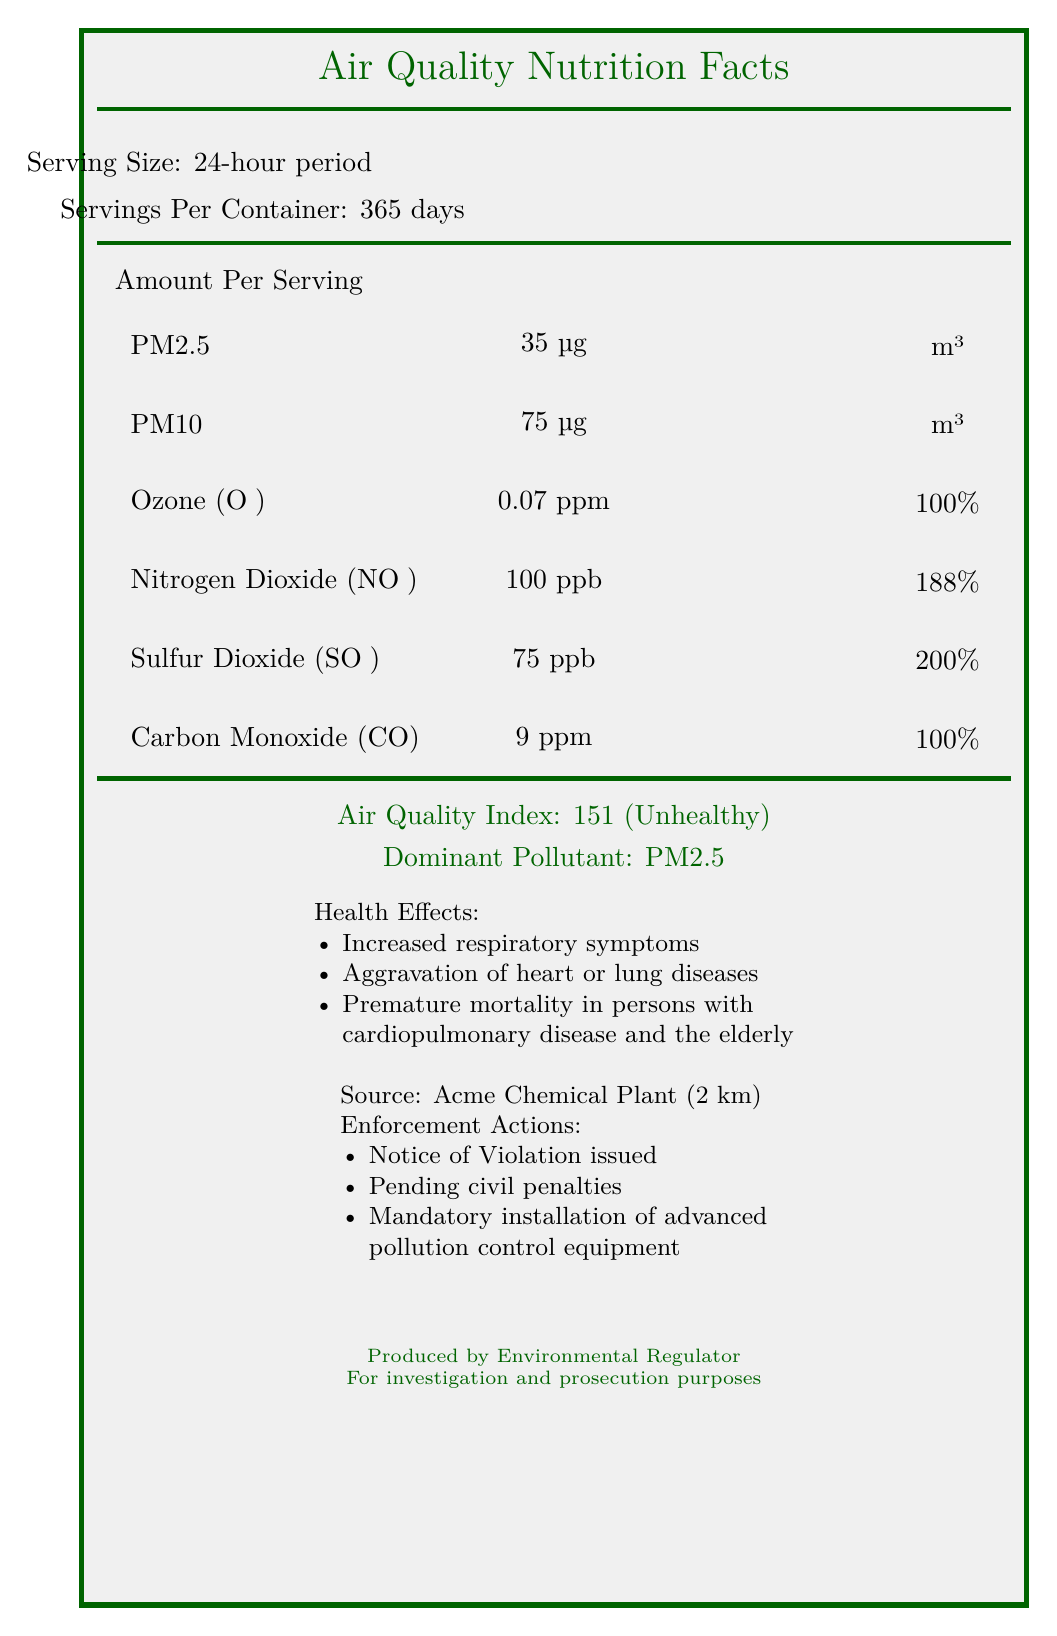who is responsible for the air quality contamination? The document explicitly states that Acme Chemical Plant is the source facility responsible for the contamination.
Answer: Acme Chemical Plant what is the serving size of air quality measurement? The document lists the serving size as a 24-hour period in the "Serving Size" section.
Answer: 24-hour period what is the air quality index (AQI) category? The document specifies that the Air Quality Index (AQI) is 151, which falls in the "Unhealthy" category.
Answer: Unhealthy what is the dominant pollutant in the air quality? The document states that the dominant pollutant is PM2.5.
Answer: PM2.5 how many schools and hospitals are affected by the pollution? According to the document, 3 schools and 1 hospital are affected by the pollution.
Answer: 3 schools and 1 hospital what are the daily values for PM10 and Nitrogen Dioxide? A. PM10: 150%, Nitrogen Dioxide: 175% B. PM10: 150%, Nitrogen Dioxide: 188% C. PM10: 100%, Nitrogen Dioxide: 150% D. PM10: 100%, Nitrogen Dioxide: 188% Based on the document, the daily values for PM10 is 150% and for Nitrogen Dioxide is 188%.
Answer: B which enforcement actions are being taken against the Acme Chemical Plant? I. Notice of Violation issued II. Mandatory shutdown III. Pending civil penalties IV. Community relocation The document states that the enforcement actions include "Notice of Violation issued," "Pending civil penalties," and "Mandatory installation of advanced pollution control equipment". Community relocation is not listed.
Answer: I, III, IV has the company violated regulations before? The document states that there have been previous violations, specifically 2 listed in the compliance history.
Answer: Yes summarize the main issues presented in the document. The document mainly covers the air quality index and particulate matter concentrations around Acme Chemical Plant, including pollutant levels, health effects, regulatory violations, and measures taken for mitigation, targeting both regulation and community awareness.
Answer: The document provides a detailed overview of air quality issues and contaminants caused by the Acme Chemical Plant, listing various pollutants and their concentrations exceeding regulatory limits. It highlights the health effects and enforcement actions, documenting the community impact and historical compliance violations. what is the temperature and wind speed in the surrounding areas? The meteorological conditions section mentions a temperature of 25°C and wind speed of 5 mph.
Answer: 25°C and 5 mph are the measured levels of PM2.5 within regulatory limits? The document shows that the measured PM2.5 level is 35 µg/m³, which is the regulatory limit for a 24-hour average.
Answer: Yes how many square kilometers of residential areas are affected? The document states that 5 square kilometers of residential areas are affected by the pollution.
Answer: 5 square km what was the date of the last inspection of the facility? The compliance history section of the document states that the last inspection date was March 15, 2023.
Answer: 2023-03-15 does the document include information about the annual average levels of pollutants? The document only provides information based on a 24-hour period, not the annual average levels for pollutants.
Answer: No 